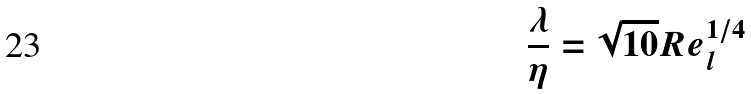<formula> <loc_0><loc_0><loc_500><loc_500>\frac { \lambda } { \eta } = \sqrt { 1 0 } R e _ { l } ^ { 1 / 4 }</formula> 